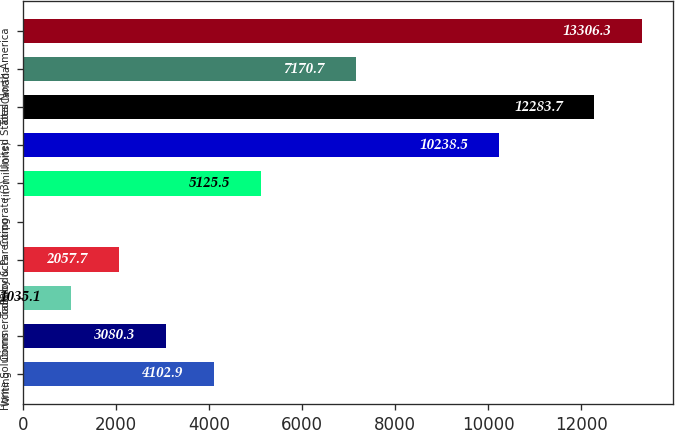Convert chart to OTSL. <chart><loc_0><loc_0><loc_500><loc_500><bar_chart><fcel>Writing<fcel>Home Solutions<fcel>Tools<fcel>Commercial Products<fcel>Baby & Parenting<fcel>Corporate (3)<fcel>(in millions)<fcel>United States<fcel>Canada<fcel>Total North America<nl><fcel>4102.9<fcel>3080.3<fcel>1035.1<fcel>2057.7<fcel>12.5<fcel>5125.5<fcel>10238.5<fcel>12283.7<fcel>7170.7<fcel>13306.3<nl></chart> 